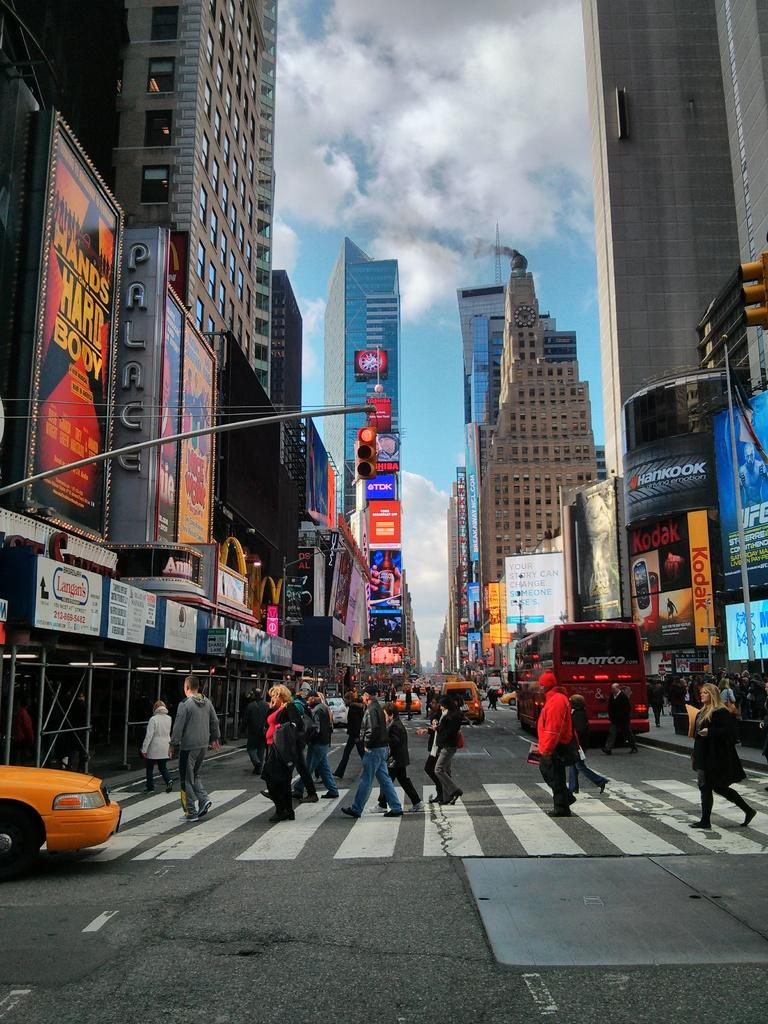<image>
Offer a succinct explanation of the picture presented. a sign that says hands on a hard body with a steet next to it 